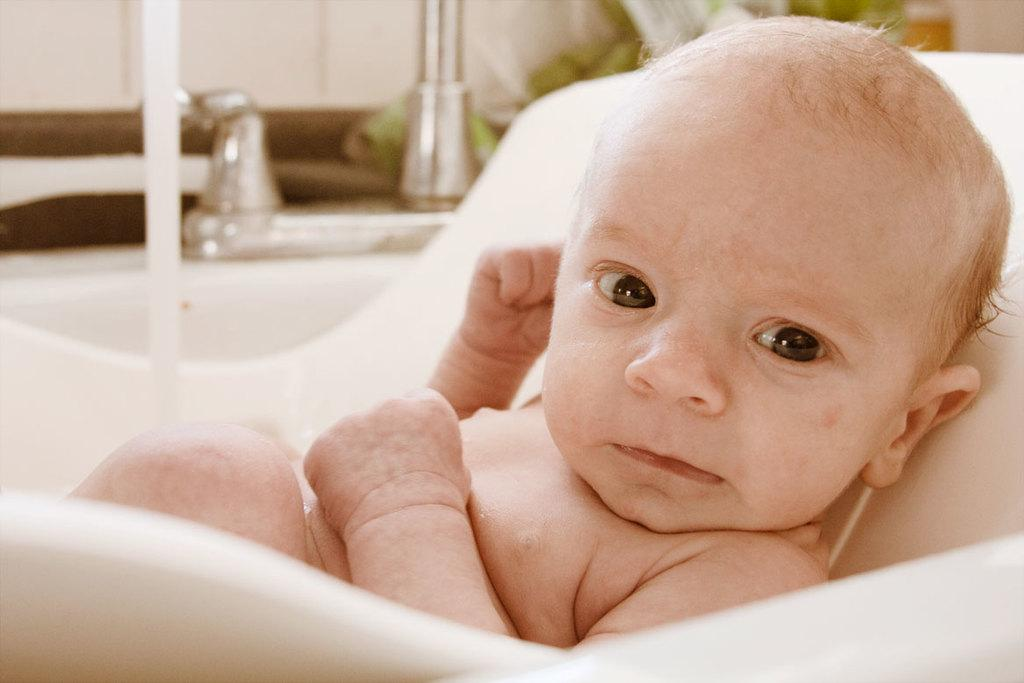What is the main subject of the image? There is a baby in the image. Where is the baby located? The baby is on a chair in the image. What else can be seen in the image besides the baby? There is a pole and a wall in the image. How many bears are visible in the image? There are no bears present in the image. What type of office is shown in the image? There is no office depicted in the image; it features a baby on a chair with a pole and a wall in the background. 